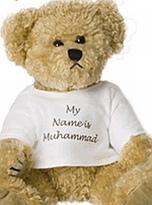What aspect of this image offended some Muslims a few years ago?
Give a very brief answer. Name. Is the bear smiling?
Quick response, please. No. Does this shirt need to be washed?
Quick response, please. No. 